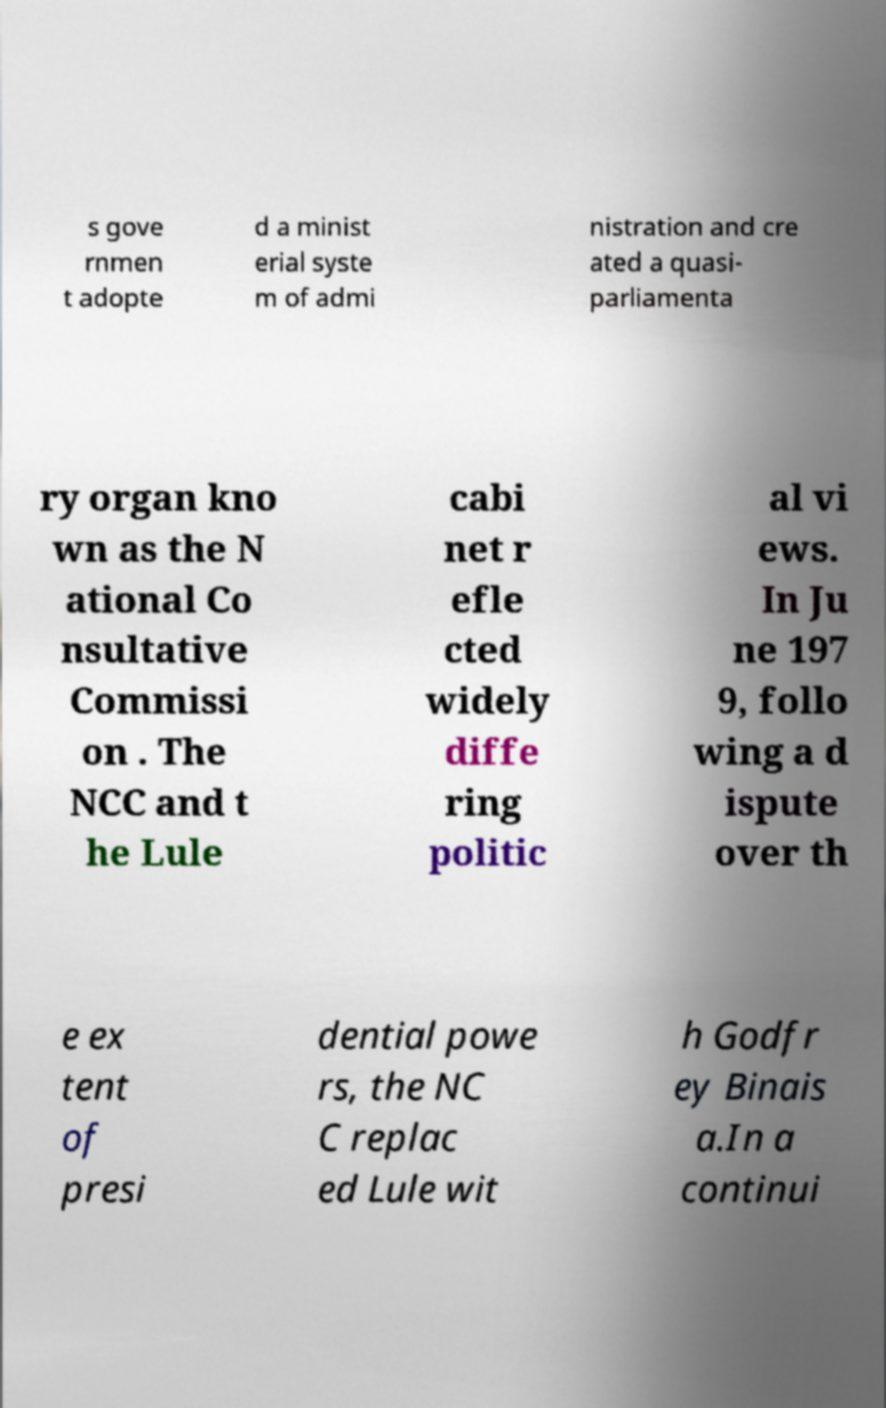I need the written content from this picture converted into text. Can you do that? s gove rnmen t adopte d a minist erial syste m of admi nistration and cre ated a quasi- parliamenta ry organ kno wn as the N ational Co nsultative Commissi on . The NCC and t he Lule cabi net r efle cted widely diffe ring politic al vi ews. In Ju ne 197 9, follo wing a d ispute over th e ex tent of presi dential powe rs, the NC C replac ed Lule wit h Godfr ey Binais a.In a continui 